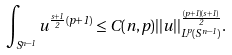<formula> <loc_0><loc_0><loc_500><loc_500>\int _ { S ^ { n - 1 } } u ^ { \frac { s + 1 } { 2 } ( p + 1 ) } \leq C ( n , p ) | | u | | _ { L ^ { p } ( S ^ { n - 1 } ) } ^ { \frac { ( p + 1 ) ( s + 1 ) } { 2 } } .</formula> 